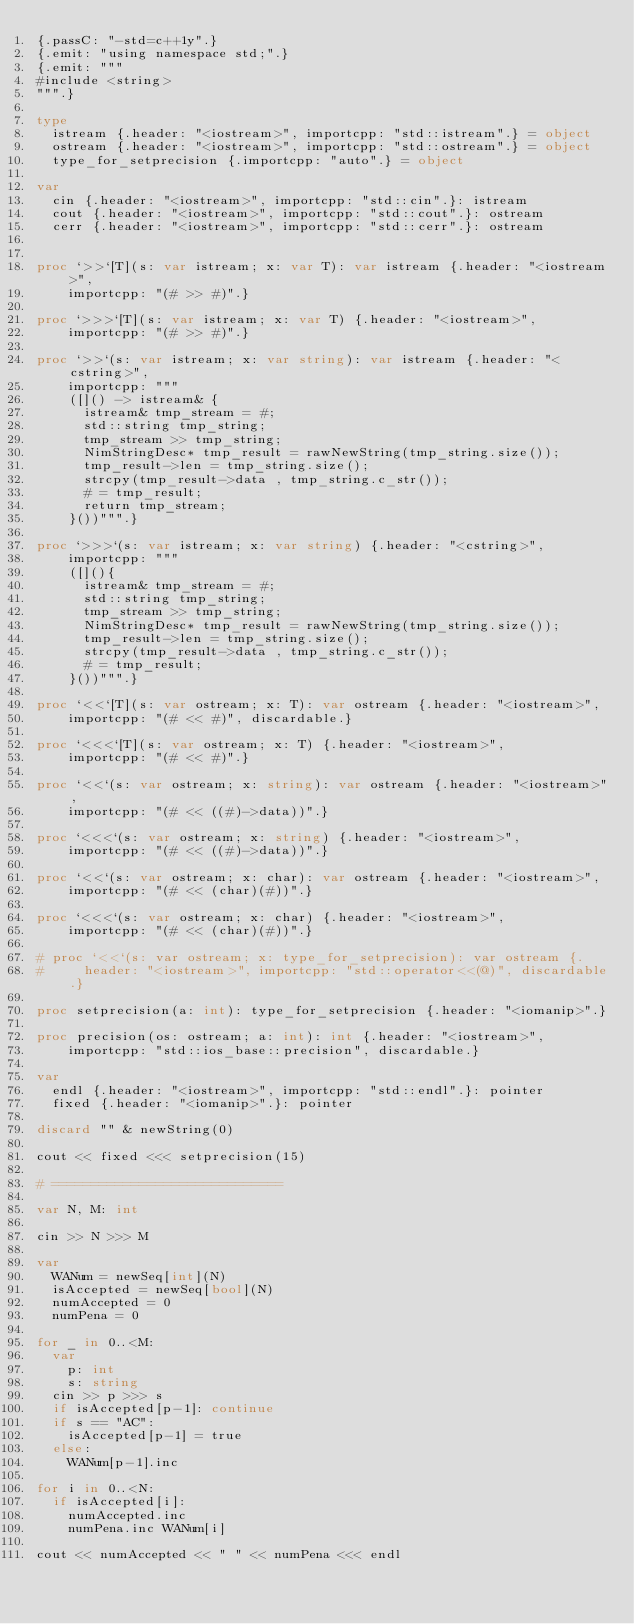Convert code to text. <code><loc_0><loc_0><loc_500><loc_500><_Nim_>{.passC: "-std=c++1y".}
{.emit: "using namespace std;".}
{.emit: """
#include <string>
""".}

type
  istream {.header: "<iostream>", importcpp: "std::istream".} = object
  ostream {.header: "<iostream>", importcpp: "std::ostream".} = object
  type_for_setprecision {.importcpp: "auto".} = object

var
  cin {.header: "<iostream>", importcpp: "std::cin".}: istream
  cout {.header: "<iostream>", importcpp: "std::cout".}: ostream
  cerr {.header: "<iostream>", importcpp: "std::cerr".}: ostream


proc `>>`[T](s: var istream; x: var T): var istream {.header: "<iostream>",
    importcpp: "(# >> #)".}

proc `>>>`[T](s: var istream; x: var T) {.header: "<iostream>",
    importcpp: "(# >> #)".}

proc `>>`(s: var istream; x: var string): var istream {.header: "<cstring>",
    importcpp: """
    ([]() -> istream& {
      istream& tmp_stream = #;
      std::string tmp_string;
      tmp_stream >> tmp_string;
      NimStringDesc* tmp_result = rawNewString(tmp_string.size());
      tmp_result->len = tmp_string.size();
      strcpy(tmp_result->data , tmp_string.c_str());
      # = tmp_result;
      return tmp_stream;
    }())""".}

proc `>>>`(s: var istream; x: var string) {.header: "<cstring>",
    importcpp: """
    ([](){
      istream& tmp_stream = #;
      std::string tmp_string;
      tmp_stream >> tmp_string;
      NimStringDesc* tmp_result = rawNewString(tmp_string.size());
      tmp_result->len = tmp_string.size();
      strcpy(tmp_result->data , tmp_string.c_str());
      # = tmp_result;
    }())""".}

proc `<<`[T](s: var ostream; x: T): var ostream {.header: "<iostream>",
    importcpp: "(# << #)", discardable.}

proc `<<<`[T](s: var ostream; x: T) {.header: "<iostream>",
    importcpp: "(# << #)".}

proc `<<`(s: var ostream; x: string): var ostream {.header: "<iostream>",
    importcpp: "(# << ((#)->data))".}

proc `<<<`(s: var ostream; x: string) {.header: "<iostream>",
    importcpp: "(# << ((#)->data))".}

proc `<<`(s: var ostream; x: char): var ostream {.header: "<iostream>",
    importcpp: "(# << (char)(#))".}

proc `<<<`(s: var ostream; x: char) {.header: "<iostream>",
    importcpp: "(# << (char)(#))".}

# proc `<<`(s: var ostream; x: type_for_setprecision): var ostream {.
#     header: "<iostream>", importcpp: "std::operator<<(@)", discardable.}

proc setprecision(a: int): type_for_setprecision {.header: "<iomanip>".}

proc precision(os: ostream; a: int): int {.header: "<iostream>",
    importcpp: "std::ios_base::precision", discardable.}

var
  endl {.header: "<iostream>", importcpp: "std::endl".}: pointer
  fixed {.header: "<iomanip>".}: pointer

discard "" & newString(0)

cout << fixed <<< setprecision(15)

# =============================

var N, M: int

cin >> N >>> M

var
  WANum = newSeq[int](N)
  isAccepted = newSeq[bool](N)
  numAccepted = 0
  numPena = 0

for _ in 0..<M:
  var
    p: int
    s: string
  cin >> p >>> s
  if isAccepted[p-1]: continue
  if s == "AC":
    isAccepted[p-1] = true
  else:
    WANum[p-1].inc

for i in 0..<N:
  if isAccepted[i]:
    numAccepted.inc
    numPena.inc WANum[i]

cout << numAccepted << " " << numPena <<< endl
</code> 